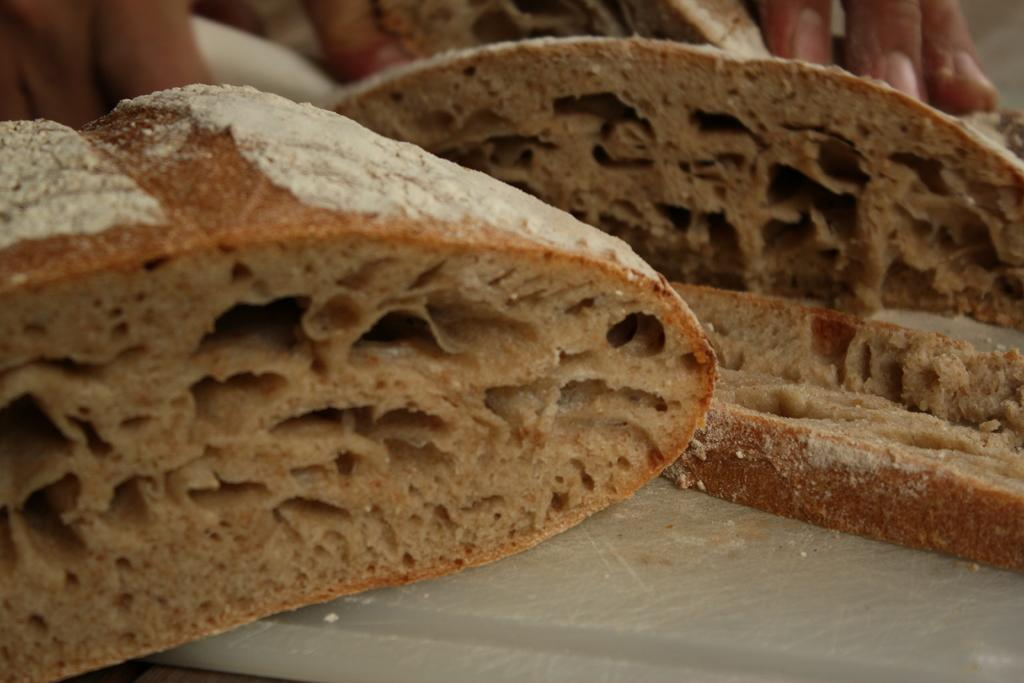What type of food can be seen in the image? There are pieces of bread in the image. Whose hand is visible in the image? A person's hand is visible in the image. Where was the image taken? The image was taken in a room. How many cards are being held by the boys in the image? There are no boys or cards present in the image. 